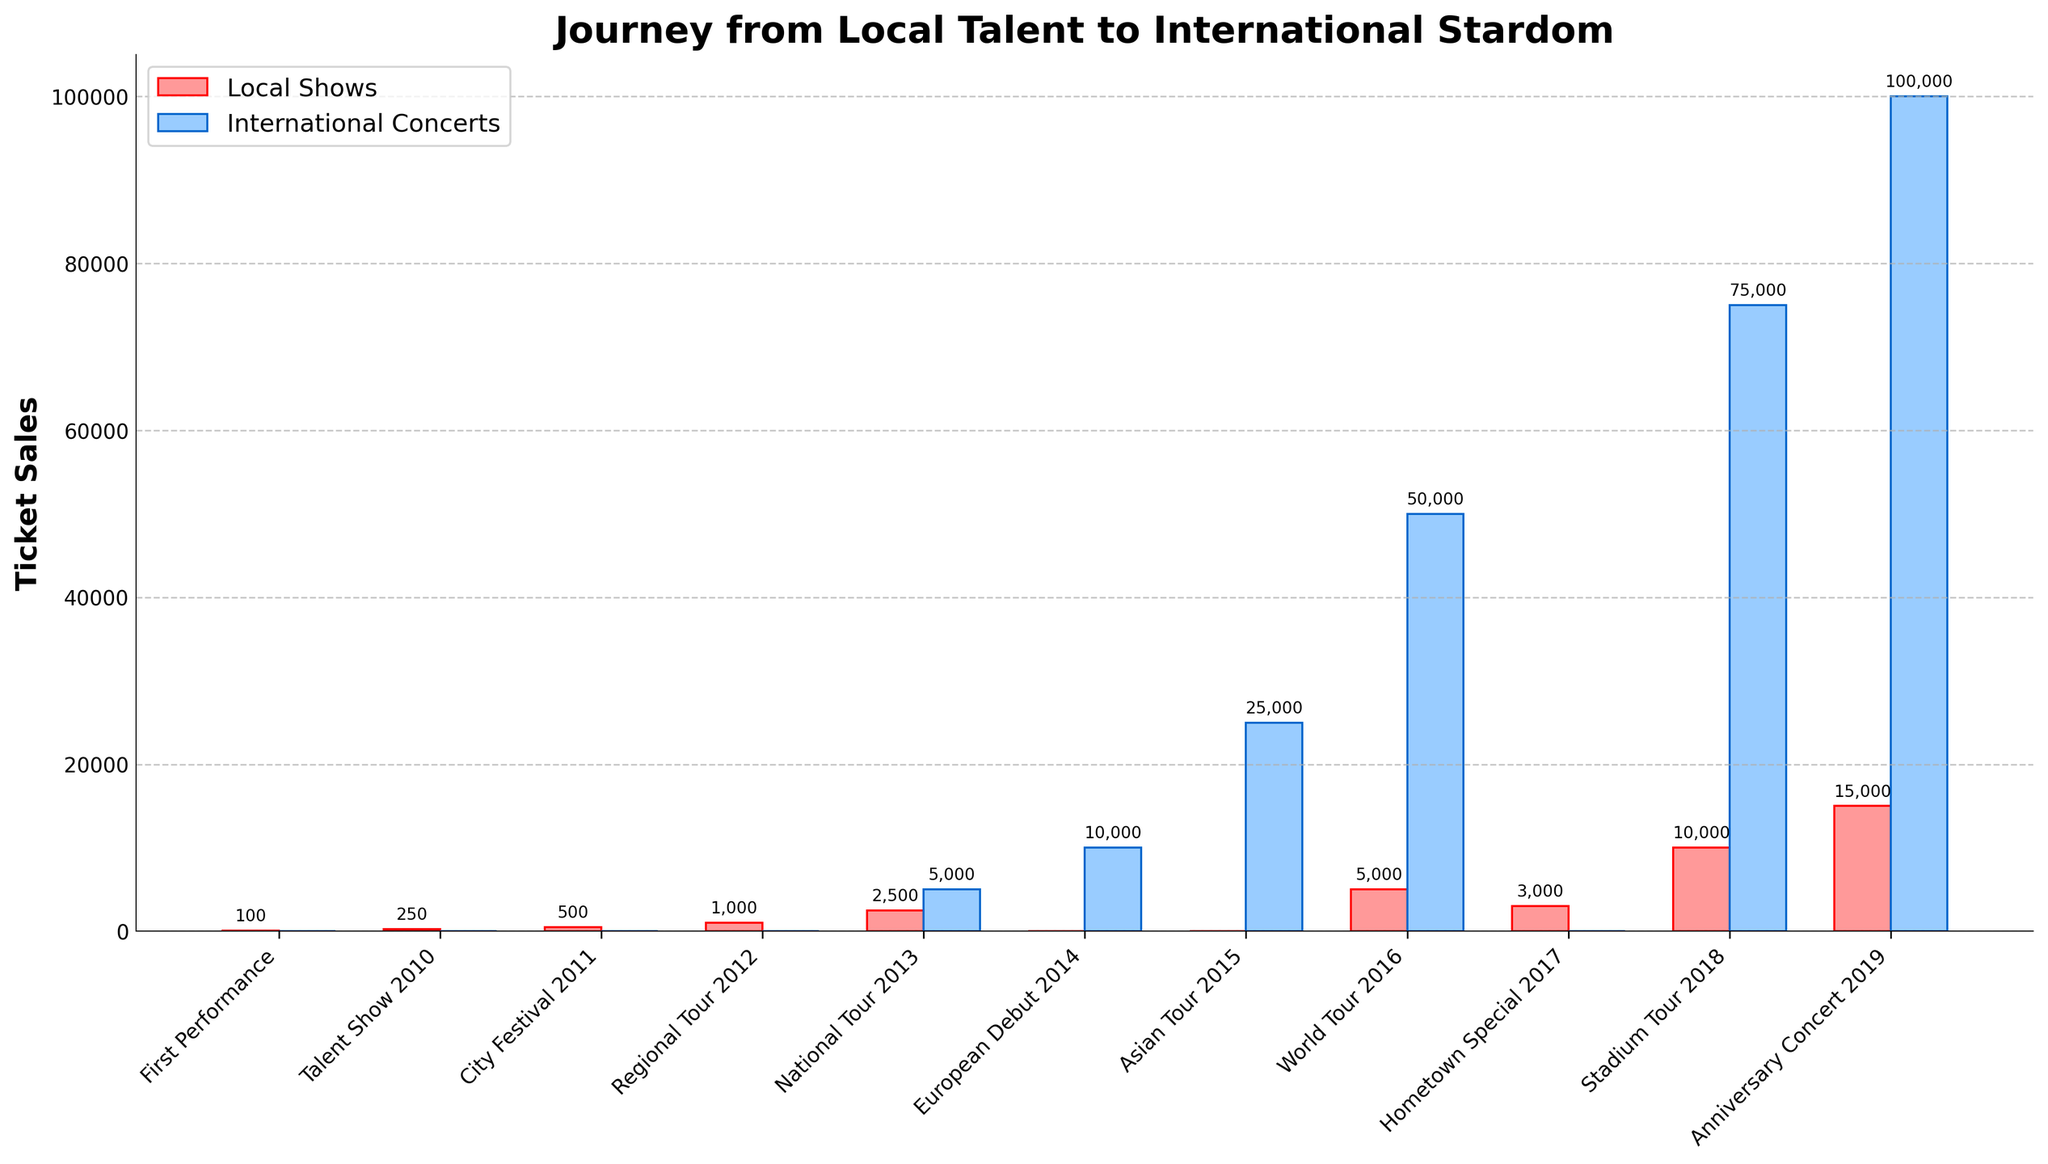What's the difference in ticket sales between the National Tour 2013 and the European Debut 2014? The ticket sales for the National Tour 2013 are 7,500 (2,500 local + 5,000 international), and the ticket sales for the European Debut 2014 are 10,000 (all international). The difference is 10,000 - 7,500 = 2,500.
Answer: 2,500 Which event had the highest local ticket sales? By scanning the heights of bars associated with local shows, the highest is the Anniversary Concert 2019 with 15,000 ticket sales.
Answer: Anniversary Concert 2019 How many events did not have any international ticket sales? The events without international ticket sales are First Performance, Talent Show 2010, City Festival 2011, Regional Tour 2012, Hometown Special 2017. Counting these events gives a total of 5.
Answer: 5 What's the total ticket sales for the World Tour 2016? The World Tour 2016 has 5,000 local tickets and 50,000 international tickets. Adding these gives 5,000 + 50,000 = 55,000.
Answer: 55,000 Compare the ticket sales of the Stadium Tour 2018 and the Hometown Special 2017 for local shows. Which event sold more? The Stadium Tour 2018 sold 10,000 local tickets, while the Hometown Special 2017 sold 3,000 local tickets. Comparing these, 10,000 is greater than 3,000.
Answer: Stadium Tour 2018 What is the average ticket sales of local shows over all events? Summing the local shows tickets (100 + 250 + 500 + 1,000 + 2,500 + 0 + 0 + 5,000 + 3,000 + 10,000 + 15,000) and dividing by the number of events (11) gives (37,350 / 11) = approximately 3,395.
Answer: 3,395 Which event had the smallest total ticket sales? Scanning the heights of the bars, the smallest total is the First Performance with 100 local and 0 international tickets equaling 100.
Answer: First Performance How did ticket sales for international concerts change from the National Tour 2013 to the Asian Tour 2015? The National Tour 2013 had 5,000 international ticket sales, and the Asian Tour 2015 had 25,000 international ticket sales. The change is 25,000 - 5,000 = 20,000.
Answer: Increased by 20,000 